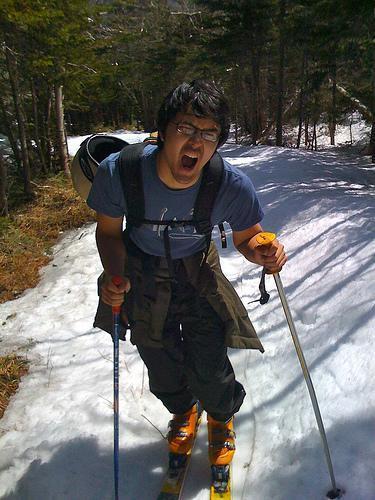How many people skiing?
Give a very brief answer. 1. 